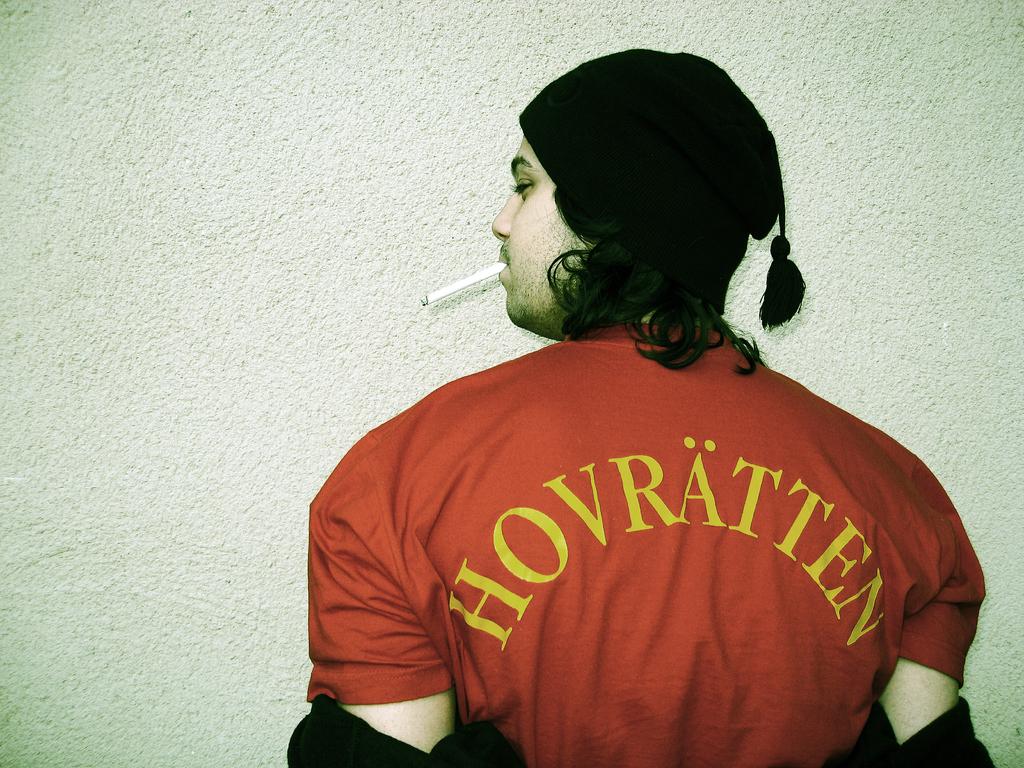What is the name of the player?
Offer a very short reply. Hovratten. 